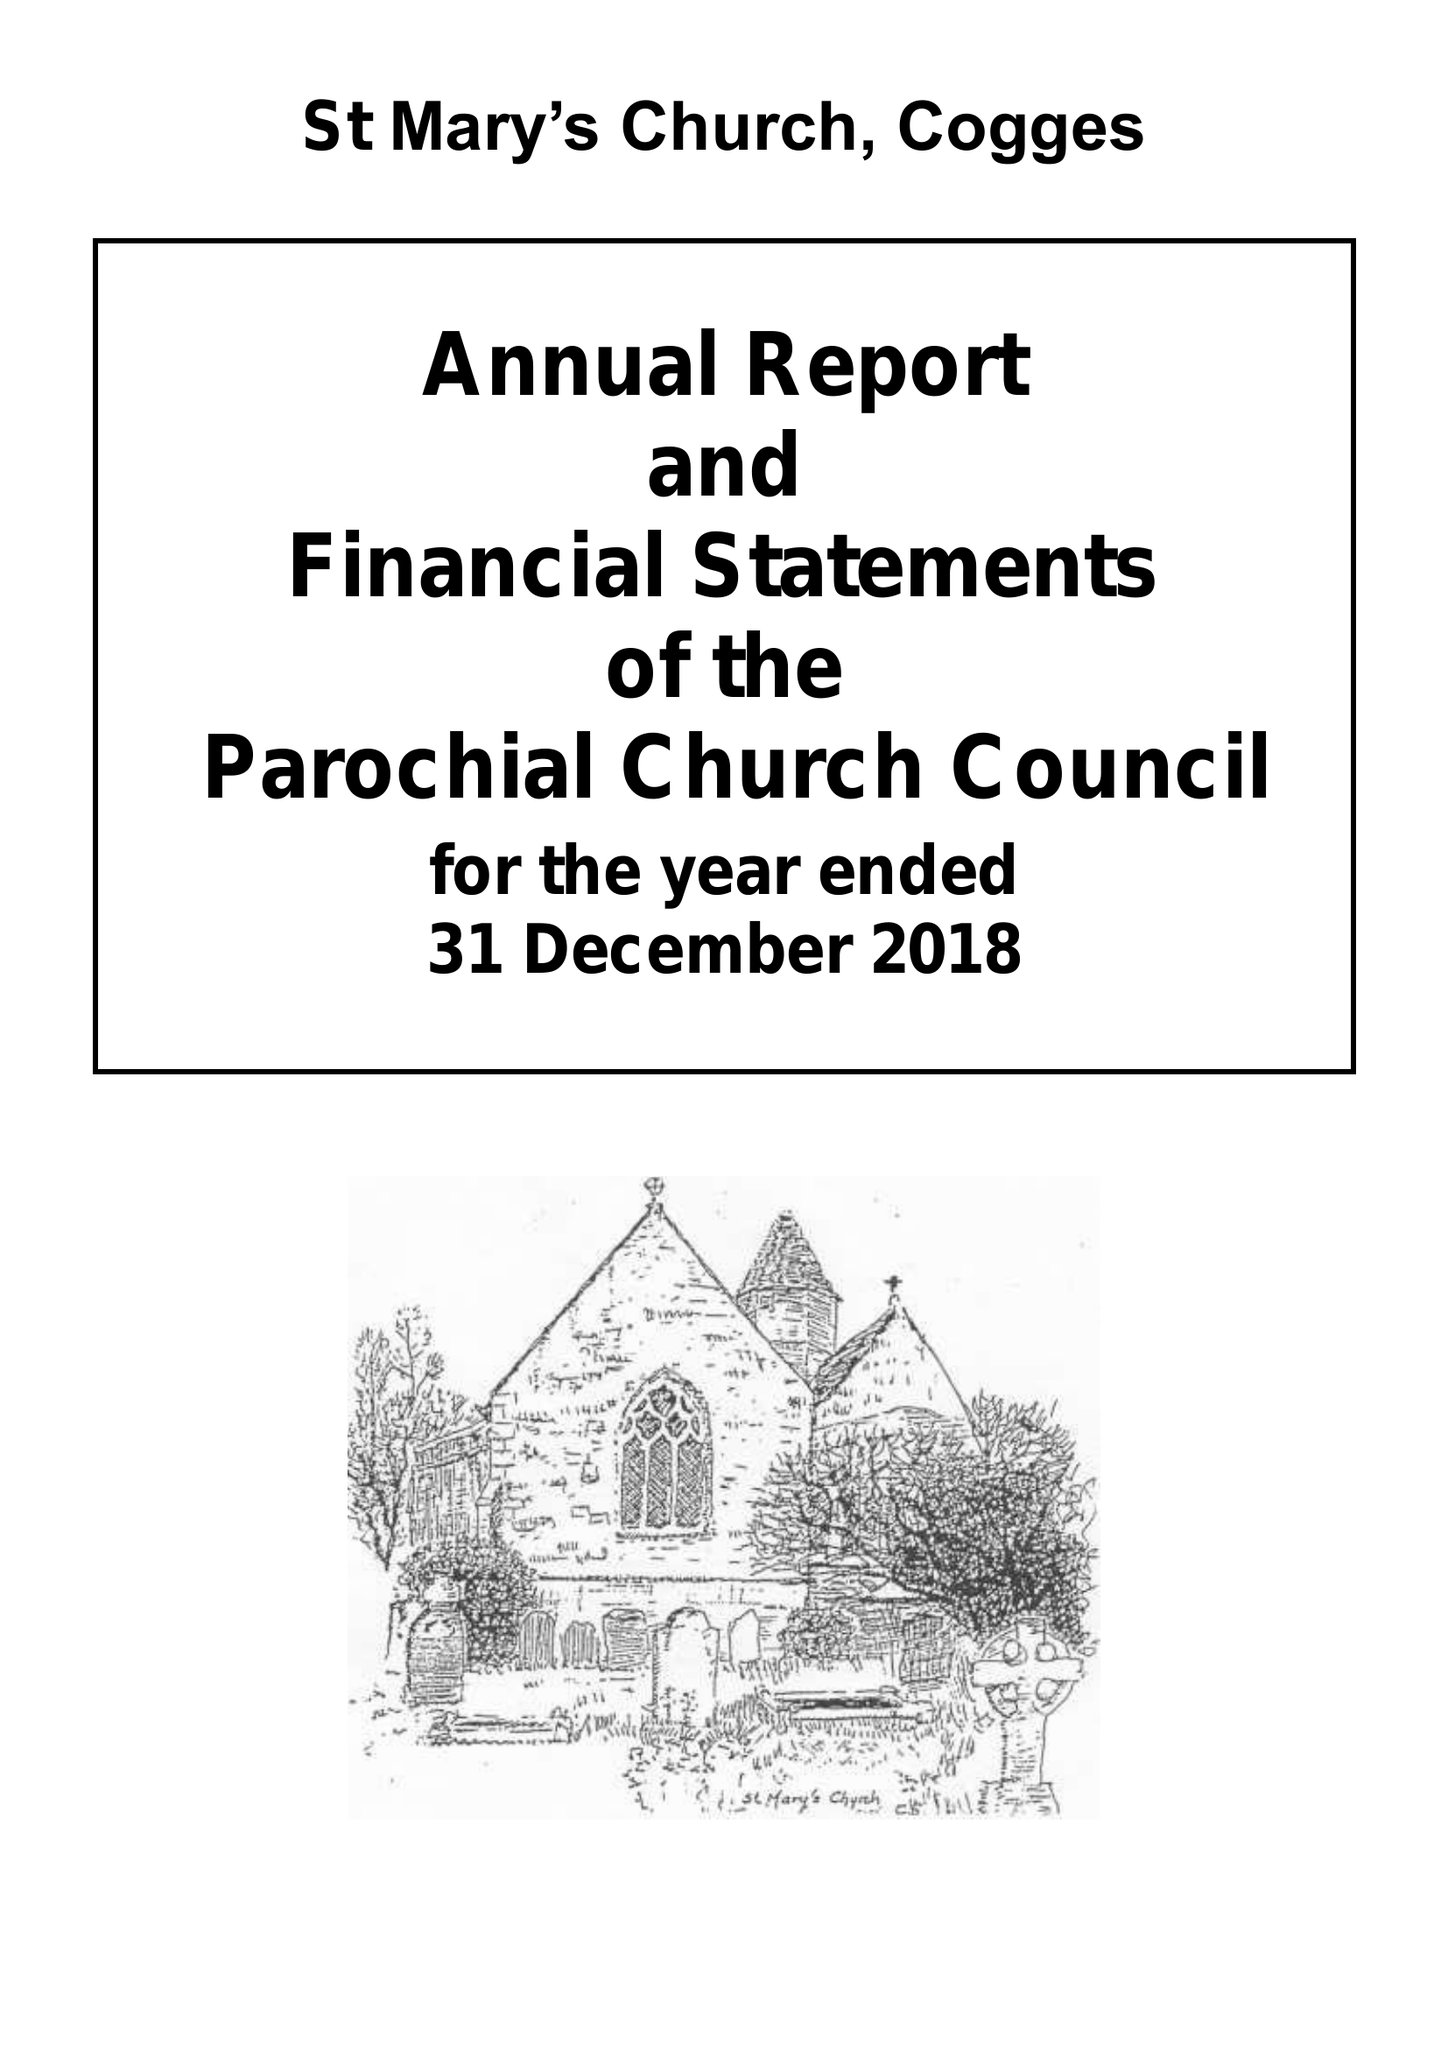What is the value for the charity_number?
Answer the question using a single word or phrase. 1129824 